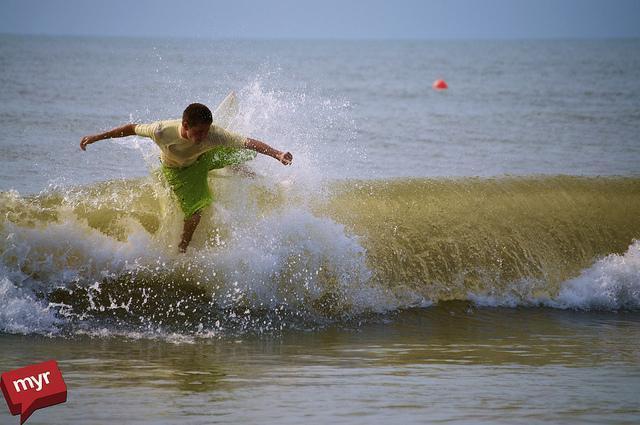How many baby elephants are there?
Give a very brief answer. 0. 